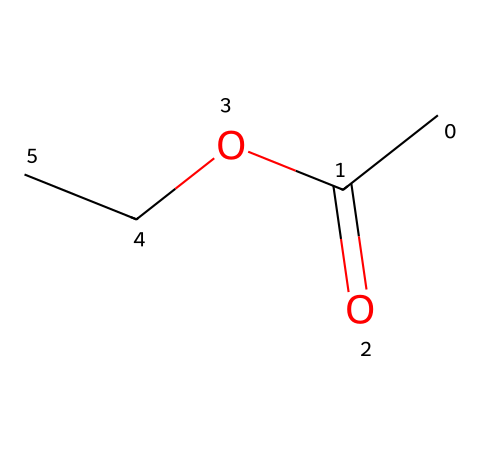What is the total number of carbon atoms in ethyl acetate? The SMILES representation CC(=O)OCC includes two carbon atoms in the ethyl group (CC) and one carbon in the carbonyl group (C=O). The total count is 2 + 1 = 3.
Answer: three How many oxygen atoms are present in ethyl acetate? In the given SMILES, there are two oxygen atoms: one in the carbonyl group (=O) and one in the ester connection (OCC).
Answer: two What functional group defines ethyl acetate as an ester? The SMILES shows the structure CC(=O)OCC, where the carbonyl group (C=O) and the oxygen atom connecting to the ethyl group (OCC) indicates the ester functional group.
Answer: ester Which element in ethyl acetate provides its characteristic sweet smell? The presence of the ester functional group (indicated by the O in its structure) is typically associated with fruity or sweet aromas.
Answer: oxygen How many hydrogen atoms are in ethyl acetate? The SMILES contributes to hydrogen determination: the two ethyl carbons contribute five hydrogen atoms and the ester’s carbonyl contributes no hydrogen, totaling H: 3 from the -OCC group. Thus, 3 + 2 = 5.
Answer: six What type of bond is present between the carbonyl carbon and the oxygen in ethyl acetate? The SMILES CC(=O)OCC shows a double bond between carbon and oxygen in the carbonyl (C=O) and a single bond to the other oxygen (C-O). The C=O indicates a double bond.
Answer: double bond What type of reaction can ethyl acetate undergo to form a carboxylic acid? Esters like ethyl acetate can undergo hydrolysis, which involves the reaction with water to break down the ester into its alcohol and carboxylic acid components.
Answer: hydrolysis 